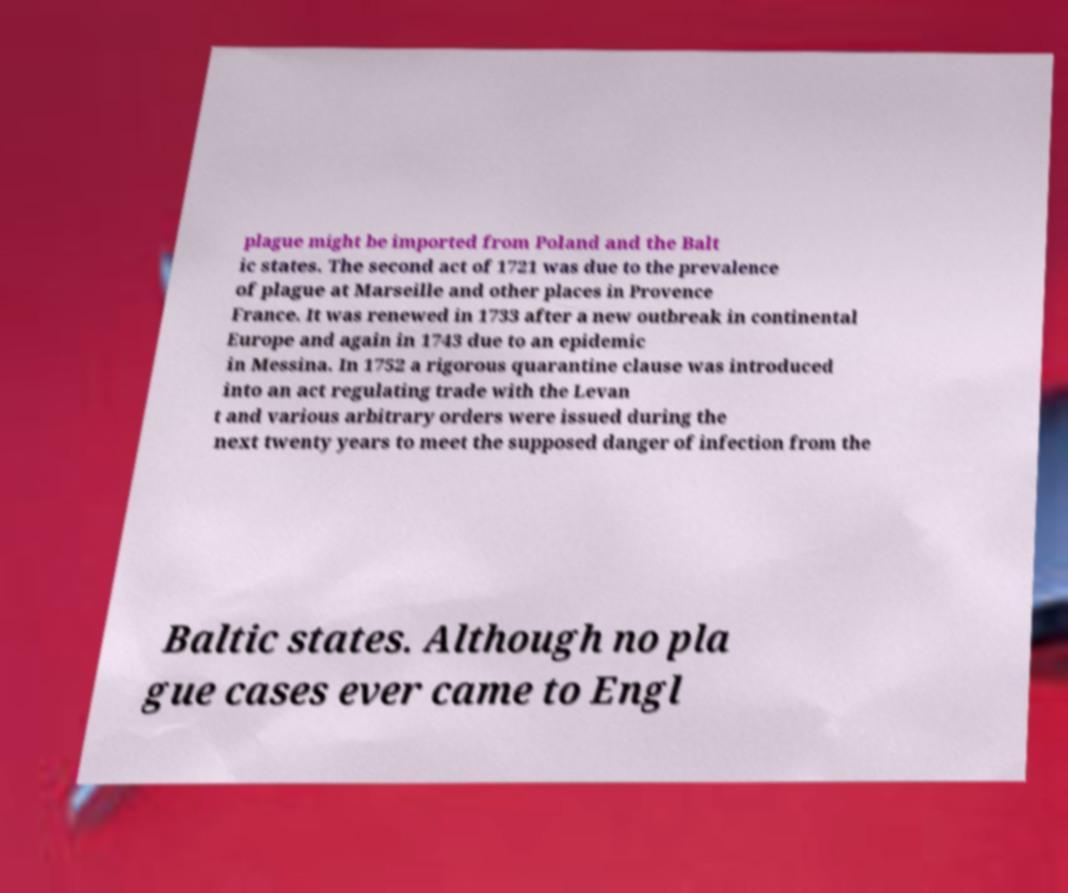Please identify and transcribe the text found in this image. plague might be imported from Poland and the Balt ic states. The second act of 1721 was due to the prevalence of plague at Marseille and other places in Provence France. It was renewed in 1733 after a new outbreak in continental Europe and again in 1743 due to an epidemic in Messina. In 1752 a rigorous quarantine clause was introduced into an act regulating trade with the Levan t and various arbitrary orders were issued during the next twenty years to meet the supposed danger of infection from the Baltic states. Although no pla gue cases ever came to Engl 